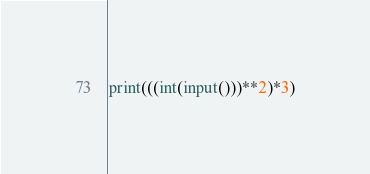Convert code to text. <code><loc_0><loc_0><loc_500><loc_500><_Python_>print(((int(input()))**2)*3)</code> 